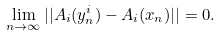<formula> <loc_0><loc_0><loc_500><loc_500>\lim _ { n \to \infty } | | A _ { i } ( y _ { n } ^ { i } ) - A _ { i } ( x _ { n } ) | | = 0 .</formula> 